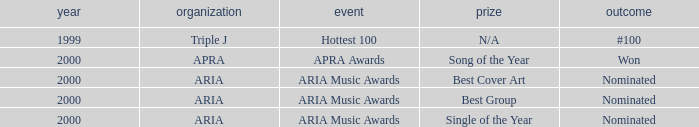Which award was nominated for in 2000? Best Cover Art, Best Group, Single of the Year. Write the full table. {'header': ['year', 'organization', 'event', 'prize', 'outcome'], 'rows': [['1999', 'Triple J', 'Hottest 100', 'N/A', '#100'], ['2000', 'APRA', 'APRA Awards', 'Song of the Year', 'Won'], ['2000', 'ARIA', 'ARIA Music Awards', 'Best Cover Art', 'Nominated'], ['2000', 'ARIA', 'ARIA Music Awards', 'Best Group', 'Nominated'], ['2000', 'ARIA', 'ARIA Music Awards', 'Single of the Year', 'Nominated']]} 